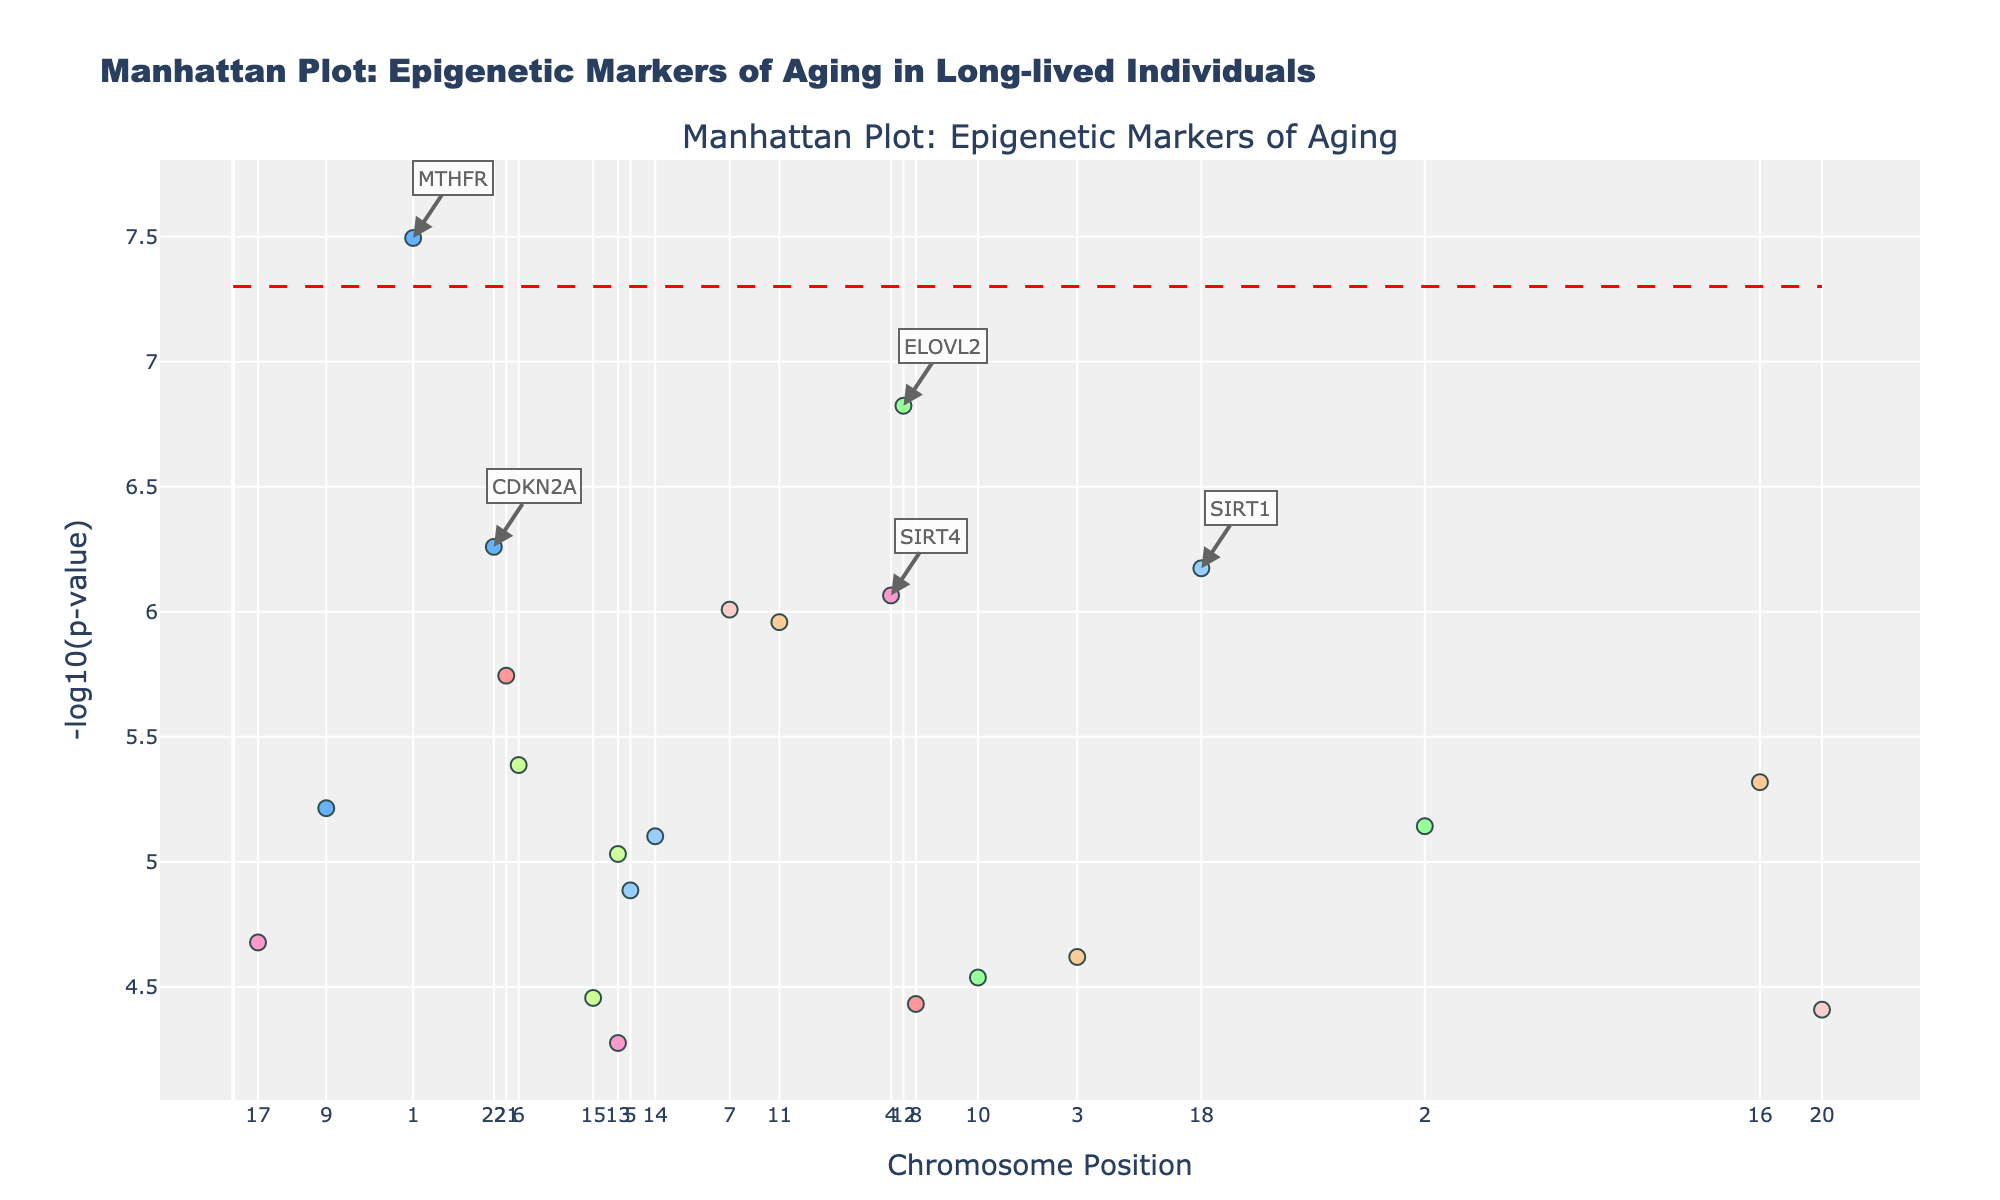What is the title of the plot? The title is usually displayed at the top of the plot. In this case, it's "Manhattan Plot: Epigenetic Markers of Aging in Long-lived Individuals".
Answer: Manhattan Plot: Epigenetic Markers of Aging in Long-lived Individuals What does the y-axis represent? The y-axis typically represents the measurement being visualized. Here, it represents the "-log10(p-value)".
Answer: -log10(p-value) How many chromosomes are shown in the plot? Chromosomes in the plot are marked along the x-axis or represented by different colored markers. There are labels for each chromosome from 1 to 22.
Answer: 22 Which gene has the highest -log10(p-value)? The highest -log10(p-value) would be the highest point on the y-axis. The gene at this position is labeled on the plot.
Answer: MTHFR What is the significance line indicating? The horizontal significance line indicates a critical p-value threshold, often used to highlight statistically significant results. The line is drawn at -log10(5e-8) on the y-axis.
Answer: It indicates a p-value threshold of 5e-8 Which chromosomes have points below the significance line? Points below the significance line lie below the red, dashed horizontal line. Observing these points, you can see they exist on multiple chromosomes.
Answer: Multiple chromosomes, including 2, 3, 4, 6, 7 What color represents chromosome 1? Individual colors represent each chromosome. By identifying chromosome 1's marker, you can determine its color.
Answer: Salmon pink How do the positions of the top 5 genes compare against the significance line? The positions of the top 5 genes and their y-values relative to the significance line can be observed directly. They are all significantly above the line, indicating strong significance.
Answer: All above the significance line Which chromosome has the gene FOXO3? Each gene's chromosome can be identified by locating the gene on the plot and checking the x-axis or color coding.
Answer: Chromosome 6 Is there any chromosome that has more than one significant gene? By observing the points above the significance line and seeing if multiple points come from the same chromosome, we can verify. No chromosome has more than one colored point above the line.
Answer: No 